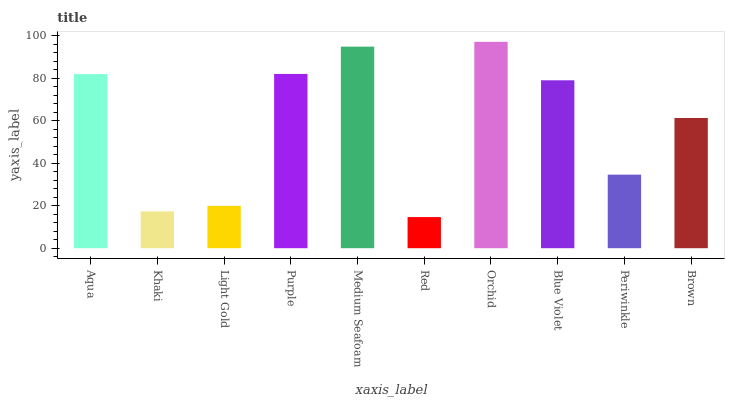Is Red the minimum?
Answer yes or no. Yes. Is Orchid the maximum?
Answer yes or no. Yes. Is Khaki the minimum?
Answer yes or no. No. Is Khaki the maximum?
Answer yes or no. No. Is Aqua greater than Khaki?
Answer yes or no. Yes. Is Khaki less than Aqua?
Answer yes or no. Yes. Is Khaki greater than Aqua?
Answer yes or no. No. Is Aqua less than Khaki?
Answer yes or no. No. Is Blue Violet the high median?
Answer yes or no. Yes. Is Brown the low median?
Answer yes or no. Yes. Is Light Gold the high median?
Answer yes or no. No. Is Blue Violet the low median?
Answer yes or no. No. 